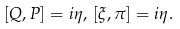Convert formula to latex. <formula><loc_0><loc_0><loc_500><loc_500>[ Q , P ] = i \eta , \, [ \xi , \pi ] = i \eta .</formula> 